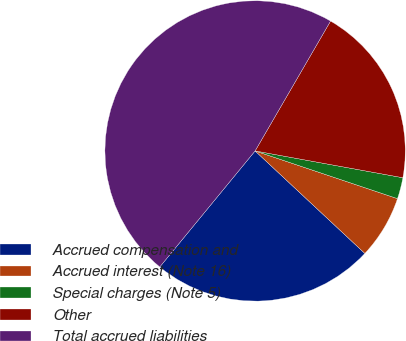<chart> <loc_0><loc_0><loc_500><loc_500><pie_chart><fcel>Accrued compensation and<fcel>Accrued interest (Note 16)<fcel>Special charges (Note 5)<fcel>Other<fcel>Total accrued liabilities<nl><fcel>23.99%<fcel>6.81%<fcel>2.29%<fcel>19.48%<fcel>47.43%<nl></chart> 